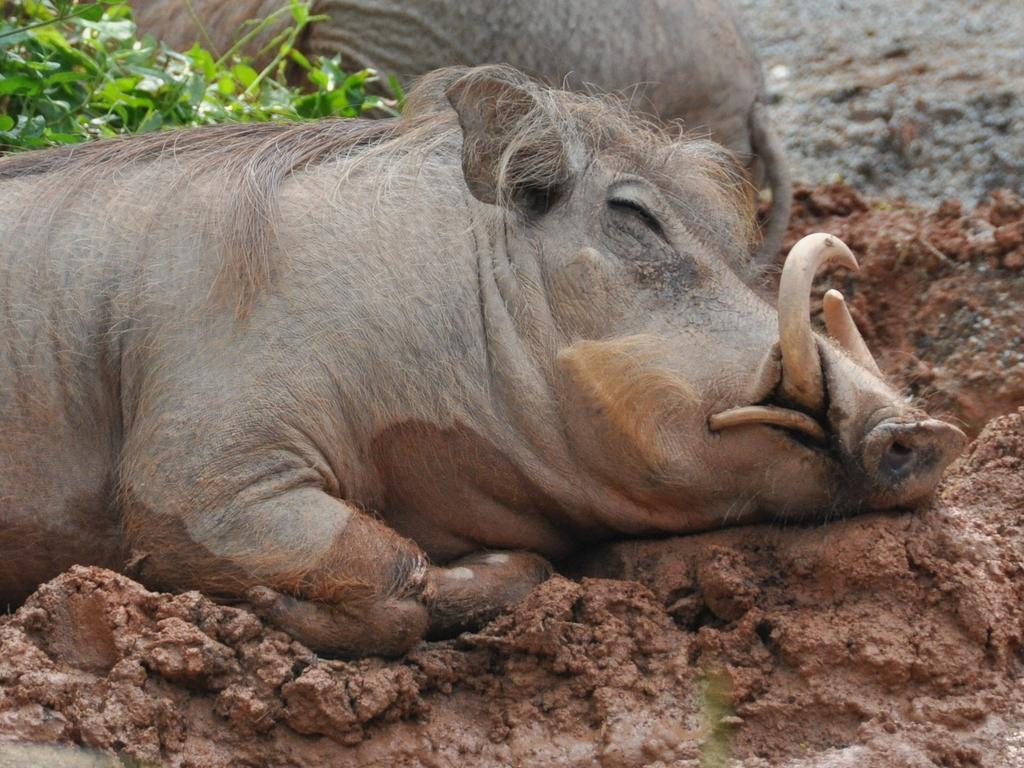What animal is present in the image? There is a boar in the image. What is the boar's position in the image? The boar is lying on the mud. What type of vegetation can be seen in the image? There are plants in the image. What color is the stocking on the boar's chin in the image? There is no stocking or chin present on the boar in the image; it is a wild animal lying on the mud. 